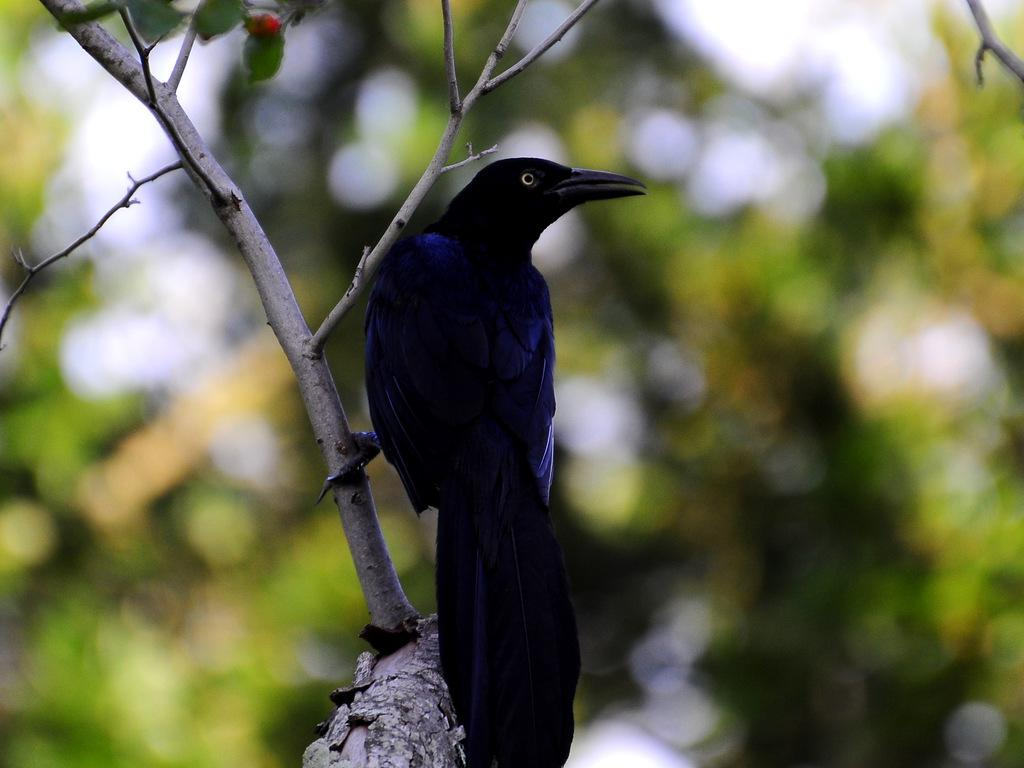What animal can be seen in the image? There is a bird on a tree in the image. Can you describe the bird's location? The bird is on a tree in the image. What else can be seen in the background of the image? There are additional trees visible in the background of the image. How many dolls are sleeping on the branches of the tree in the image? There are no dolls present in the image, and the bird is not sleeping on the tree. 